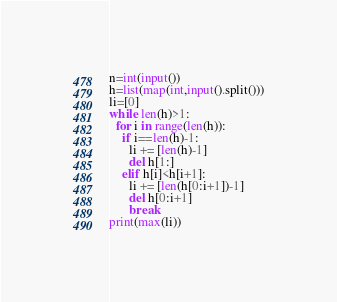<code> <loc_0><loc_0><loc_500><loc_500><_Python_>n=int(input())
h=list(map(int,input().split()))
li=[0]
while len(h)>1:
  for i in range(len(h)):
    if i==len(h)-1:
      li += [len(h)-1]
      del h[1:]
    elif h[i]<h[i+1]:
      li += [len(h[0:i+1])-1]
      del h[0:i+1]
      break
print(max(li))</code> 